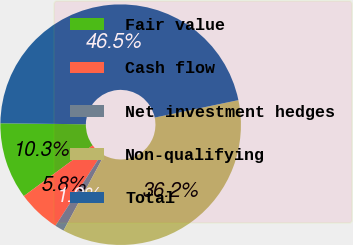<chart> <loc_0><loc_0><loc_500><loc_500><pie_chart><fcel>Fair value<fcel>Cash flow<fcel>Net investment hedges<fcel>Non-qualifying<fcel>Total<nl><fcel>10.3%<fcel>5.77%<fcel>1.24%<fcel>36.15%<fcel>46.54%<nl></chart> 